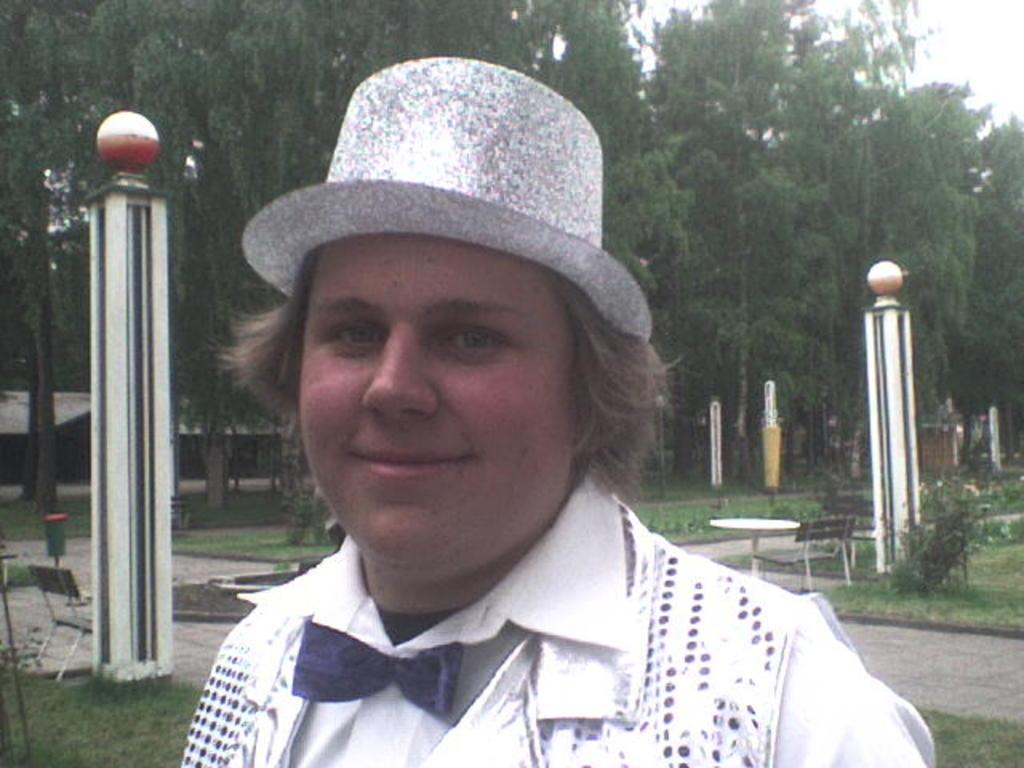What type of location is shown in the image? The image depicts a park. What is the person in the image doing? The person is standing in front of the camera and posing for a photo. What type of furniture is present in the image? There are tables and benches behind the person. Where are the tables and benches located in relation to the grass? The tables and benches are beside the grass. What letters are being sung by the yak in the image? There is no yak present in the image, and therefore no singing or letters can be observed. 